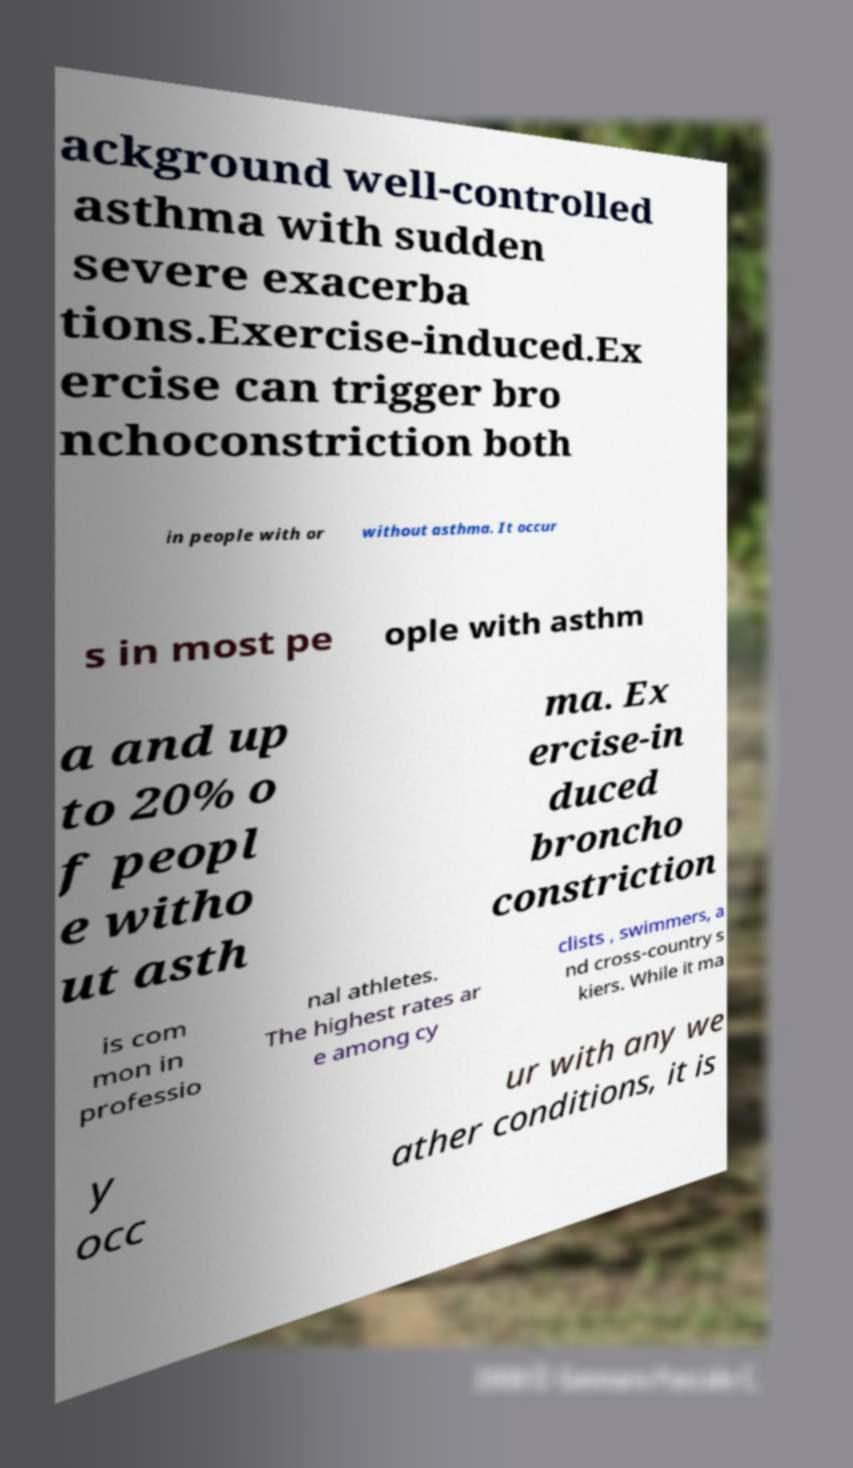I need the written content from this picture converted into text. Can you do that? ackground well-controlled asthma with sudden severe exacerba tions.Exercise-induced.Ex ercise can trigger bro nchoconstriction both in people with or without asthma. It occur s in most pe ople with asthm a and up to 20% o f peopl e witho ut asth ma. Ex ercise-in duced broncho constriction is com mon in professio nal athletes. The highest rates ar e among cy clists , swimmers, a nd cross-country s kiers. While it ma y occ ur with any we ather conditions, it is 